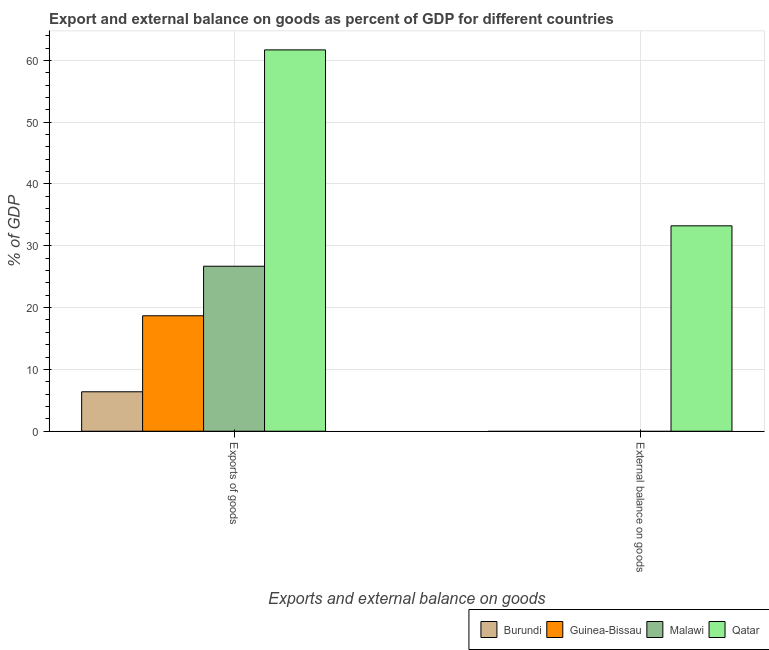Are the number of bars per tick equal to the number of legend labels?
Provide a succinct answer. No. Are the number of bars on each tick of the X-axis equal?
Offer a very short reply. No. What is the label of the 2nd group of bars from the left?
Make the answer very short. External balance on goods. Across all countries, what is the maximum external balance on goods as percentage of gdp?
Provide a short and direct response. 33.23. Across all countries, what is the minimum external balance on goods as percentage of gdp?
Keep it short and to the point. 0. In which country was the export of goods as percentage of gdp maximum?
Keep it short and to the point. Qatar. What is the total external balance on goods as percentage of gdp in the graph?
Provide a succinct answer. 33.23. What is the difference between the export of goods as percentage of gdp in Guinea-Bissau and that in Qatar?
Your answer should be compact. -43.02. What is the difference between the export of goods as percentage of gdp in Qatar and the external balance on goods as percentage of gdp in Malawi?
Your response must be concise. 61.7. What is the average export of goods as percentage of gdp per country?
Offer a very short reply. 28.36. What is the difference between the external balance on goods as percentage of gdp and export of goods as percentage of gdp in Qatar?
Offer a terse response. -28.47. What is the ratio of the export of goods as percentage of gdp in Burundi to that in Qatar?
Keep it short and to the point. 0.1. Is the export of goods as percentage of gdp in Qatar less than that in Guinea-Bissau?
Give a very brief answer. No. In how many countries, is the export of goods as percentage of gdp greater than the average export of goods as percentage of gdp taken over all countries?
Give a very brief answer. 1. How many countries are there in the graph?
Offer a terse response. 4. What is the difference between two consecutive major ticks on the Y-axis?
Provide a short and direct response. 10. Are the values on the major ticks of Y-axis written in scientific E-notation?
Offer a terse response. No. Does the graph contain any zero values?
Your answer should be compact. Yes. How many legend labels are there?
Your answer should be compact. 4. How are the legend labels stacked?
Provide a succinct answer. Horizontal. What is the title of the graph?
Provide a short and direct response. Export and external balance on goods as percent of GDP for different countries. What is the label or title of the X-axis?
Provide a short and direct response. Exports and external balance on goods. What is the label or title of the Y-axis?
Your response must be concise. % of GDP. What is the % of GDP of Burundi in Exports of goods?
Provide a succinct answer. 6.38. What is the % of GDP of Guinea-Bissau in Exports of goods?
Ensure brevity in your answer.  18.68. What is the % of GDP of Malawi in Exports of goods?
Offer a very short reply. 26.7. What is the % of GDP of Qatar in Exports of goods?
Your answer should be very brief. 61.7. What is the % of GDP of Burundi in External balance on goods?
Ensure brevity in your answer.  0. What is the % of GDP in Guinea-Bissau in External balance on goods?
Your answer should be very brief. 0. What is the % of GDP in Qatar in External balance on goods?
Ensure brevity in your answer.  33.23. Across all Exports and external balance on goods, what is the maximum % of GDP in Burundi?
Keep it short and to the point. 6.38. Across all Exports and external balance on goods, what is the maximum % of GDP in Guinea-Bissau?
Keep it short and to the point. 18.68. Across all Exports and external balance on goods, what is the maximum % of GDP in Malawi?
Provide a succinct answer. 26.7. Across all Exports and external balance on goods, what is the maximum % of GDP in Qatar?
Provide a short and direct response. 61.7. Across all Exports and external balance on goods, what is the minimum % of GDP of Burundi?
Offer a very short reply. 0. Across all Exports and external balance on goods, what is the minimum % of GDP of Qatar?
Your answer should be compact. 33.23. What is the total % of GDP in Burundi in the graph?
Offer a terse response. 6.38. What is the total % of GDP in Guinea-Bissau in the graph?
Your answer should be compact. 18.68. What is the total % of GDP of Malawi in the graph?
Your answer should be compact. 26.7. What is the total % of GDP in Qatar in the graph?
Make the answer very short. 94.93. What is the difference between the % of GDP in Qatar in Exports of goods and that in External balance on goods?
Offer a terse response. 28.47. What is the difference between the % of GDP in Burundi in Exports of goods and the % of GDP in Qatar in External balance on goods?
Offer a terse response. -26.85. What is the difference between the % of GDP of Guinea-Bissau in Exports of goods and the % of GDP of Qatar in External balance on goods?
Give a very brief answer. -14.55. What is the difference between the % of GDP of Malawi in Exports of goods and the % of GDP of Qatar in External balance on goods?
Ensure brevity in your answer.  -6.53. What is the average % of GDP in Burundi per Exports and external balance on goods?
Your answer should be very brief. 3.19. What is the average % of GDP in Guinea-Bissau per Exports and external balance on goods?
Give a very brief answer. 9.34. What is the average % of GDP of Malawi per Exports and external balance on goods?
Offer a terse response. 13.35. What is the average % of GDP of Qatar per Exports and external balance on goods?
Ensure brevity in your answer.  47.46. What is the difference between the % of GDP of Burundi and % of GDP of Guinea-Bissau in Exports of goods?
Provide a succinct answer. -12.3. What is the difference between the % of GDP in Burundi and % of GDP in Malawi in Exports of goods?
Provide a succinct answer. -20.32. What is the difference between the % of GDP of Burundi and % of GDP of Qatar in Exports of goods?
Keep it short and to the point. -55.32. What is the difference between the % of GDP in Guinea-Bissau and % of GDP in Malawi in Exports of goods?
Give a very brief answer. -8.02. What is the difference between the % of GDP in Guinea-Bissau and % of GDP in Qatar in Exports of goods?
Your answer should be compact. -43.02. What is the difference between the % of GDP in Malawi and % of GDP in Qatar in Exports of goods?
Ensure brevity in your answer.  -35. What is the ratio of the % of GDP in Qatar in Exports of goods to that in External balance on goods?
Make the answer very short. 1.86. What is the difference between the highest and the second highest % of GDP in Qatar?
Provide a succinct answer. 28.47. What is the difference between the highest and the lowest % of GDP of Burundi?
Offer a terse response. 6.38. What is the difference between the highest and the lowest % of GDP of Guinea-Bissau?
Provide a succinct answer. 18.68. What is the difference between the highest and the lowest % of GDP in Malawi?
Offer a very short reply. 26.7. What is the difference between the highest and the lowest % of GDP in Qatar?
Give a very brief answer. 28.47. 